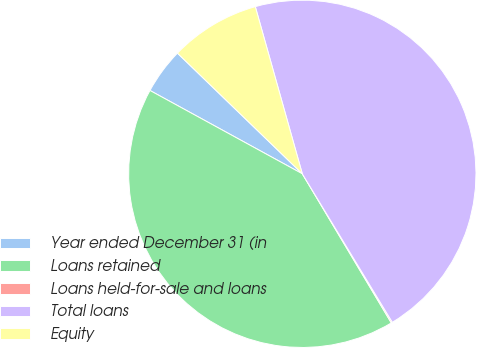Convert chart. <chart><loc_0><loc_0><loc_500><loc_500><pie_chart><fcel>Year ended December 31 (in<fcel>Loans retained<fcel>Loans held-for-sale and loans<fcel>Total loans<fcel>Equity<nl><fcel>4.26%<fcel>41.53%<fcel>0.11%<fcel>45.69%<fcel>8.41%<nl></chart> 